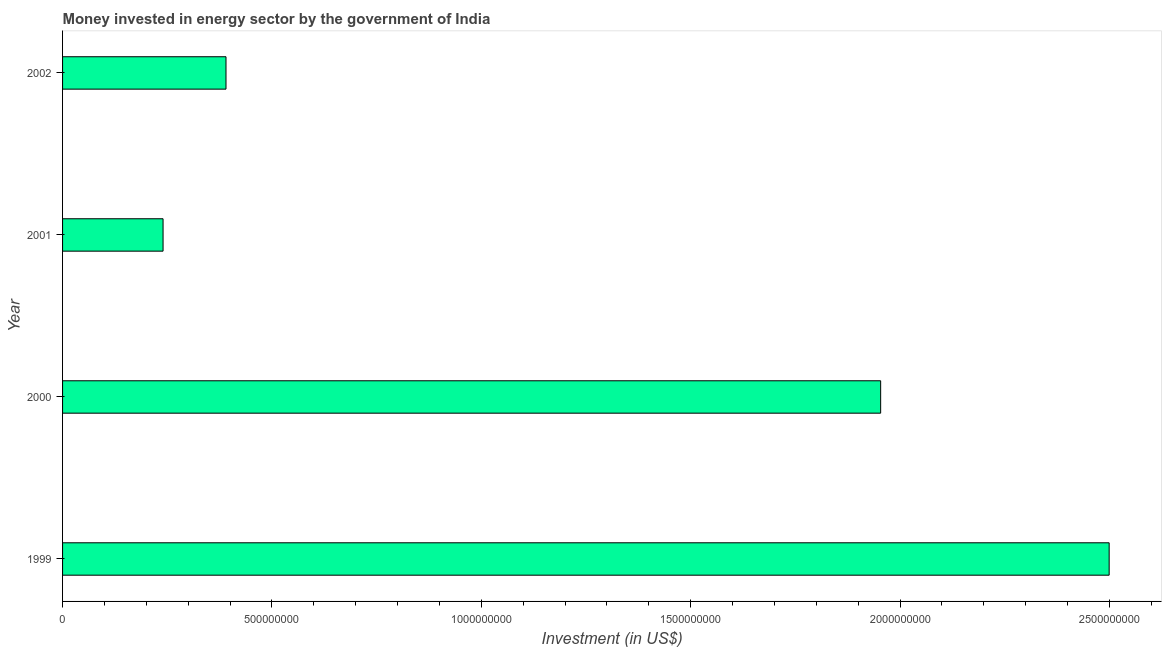Does the graph contain grids?
Offer a very short reply. No. What is the title of the graph?
Provide a succinct answer. Money invested in energy sector by the government of India. What is the label or title of the X-axis?
Make the answer very short. Investment (in US$). What is the label or title of the Y-axis?
Give a very brief answer. Year. What is the investment in energy in 2002?
Ensure brevity in your answer.  3.90e+08. Across all years, what is the maximum investment in energy?
Your answer should be compact. 2.50e+09. Across all years, what is the minimum investment in energy?
Your response must be concise. 2.40e+08. In which year was the investment in energy maximum?
Make the answer very short. 1999. What is the sum of the investment in energy?
Offer a very short reply. 5.08e+09. What is the difference between the investment in energy in 1999 and 2000?
Make the answer very short. 5.46e+08. What is the average investment in energy per year?
Keep it short and to the point. 1.27e+09. What is the median investment in energy?
Give a very brief answer. 1.17e+09. Do a majority of the years between 2002 and 2001 (inclusive) have investment in energy greater than 1000000000 US$?
Your answer should be very brief. No. What is the ratio of the investment in energy in 1999 to that in 2000?
Keep it short and to the point. 1.28. What is the difference between the highest and the second highest investment in energy?
Provide a short and direct response. 5.46e+08. What is the difference between the highest and the lowest investment in energy?
Your answer should be very brief. 2.26e+09. In how many years, is the investment in energy greater than the average investment in energy taken over all years?
Offer a terse response. 2. How many bars are there?
Your answer should be compact. 4. How many years are there in the graph?
Your answer should be very brief. 4. Are the values on the major ticks of X-axis written in scientific E-notation?
Provide a short and direct response. No. What is the Investment (in US$) of 1999?
Ensure brevity in your answer.  2.50e+09. What is the Investment (in US$) in 2000?
Your response must be concise. 1.95e+09. What is the Investment (in US$) in 2001?
Make the answer very short. 2.40e+08. What is the Investment (in US$) in 2002?
Your answer should be compact. 3.90e+08. What is the difference between the Investment (in US$) in 1999 and 2000?
Keep it short and to the point. 5.46e+08. What is the difference between the Investment (in US$) in 1999 and 2001?
Your answer should be compact. 2.26e+09. What is the difference between the Investment (in US$) in 1999 and 2002?
Give a very brief answer. 2.11e+09. What is the difference between the Investment (in US$) in 2000 and 2001?
Provide a succinct answer. 1.71e+09. What is the difference between the Investment (in US$) in 2000 and 2002?
Make the answer very short. 1.56e+09. What is the difference between the Investment (in US$) in 2001 and 2002?
Your answer should be compact. -1.50e+08. What is the ratio of the Investment (in US$) in 1999 to that in 2000?
Offer a terse response. 1.28. What is the ratio of the Investment (in US$) in 1999 to that in 2001?
Give a very brief answer. 10.41. What is the ratio of the Investment (in US$) in 1999 to that in 2002?
Your answer should be compact. 6.4. What is the ratio of the Investment (in US$) in 2000 to that in 2001?
Ensure brevity in your answer.  8.14. What is the ratio of the Investment (in US$) in 2000 to that in 2002?
Your answer should be compact. 5.01. What is the ratio of the Investment (in US$) in 2001 to that in 2002?
Give a very brief answer. 0.61. 